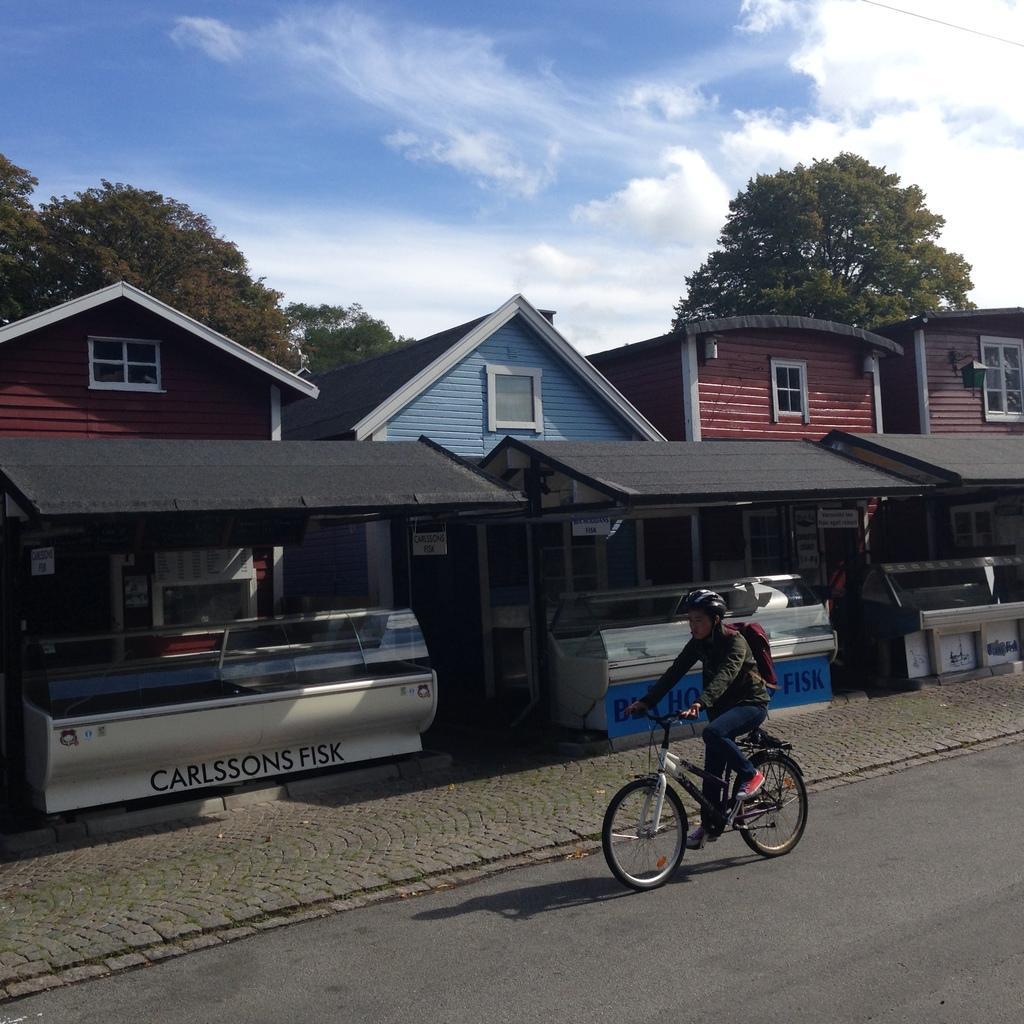In one or two sentences, can you explain what this image depicts? There is a man riding a bicycle. This is road and there are stalls. In the background we can see houses, windows, trees, and sky with clouds. 